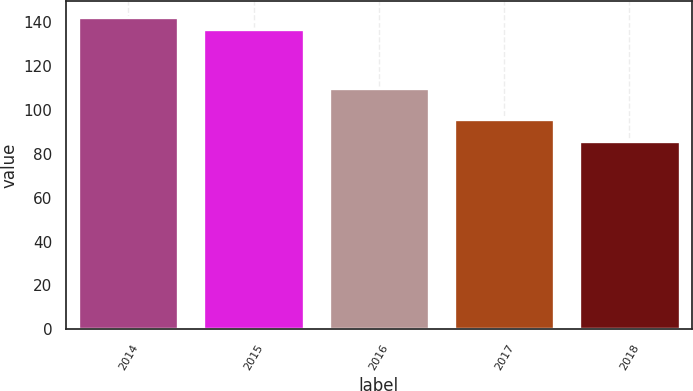Convert chart to OTSL. <chart><loc_0><loc_0><loc_500><loc_500><bar_chart><fcel>2014<fcel>2015<fcel>2016<fcel>2017<fcel>2018<nl><fcel>142.5<fcel>137<fcel>110<fcel>96<fcel>86<nl></chart> 